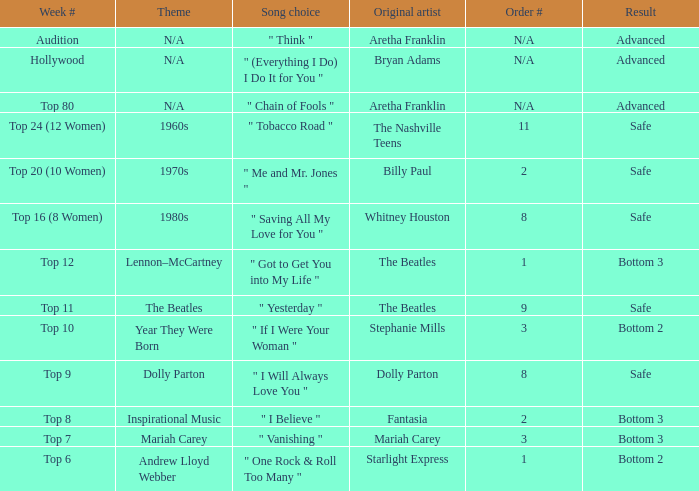Identify the sequence number for the beatles and outcome is secure. 9.0. 